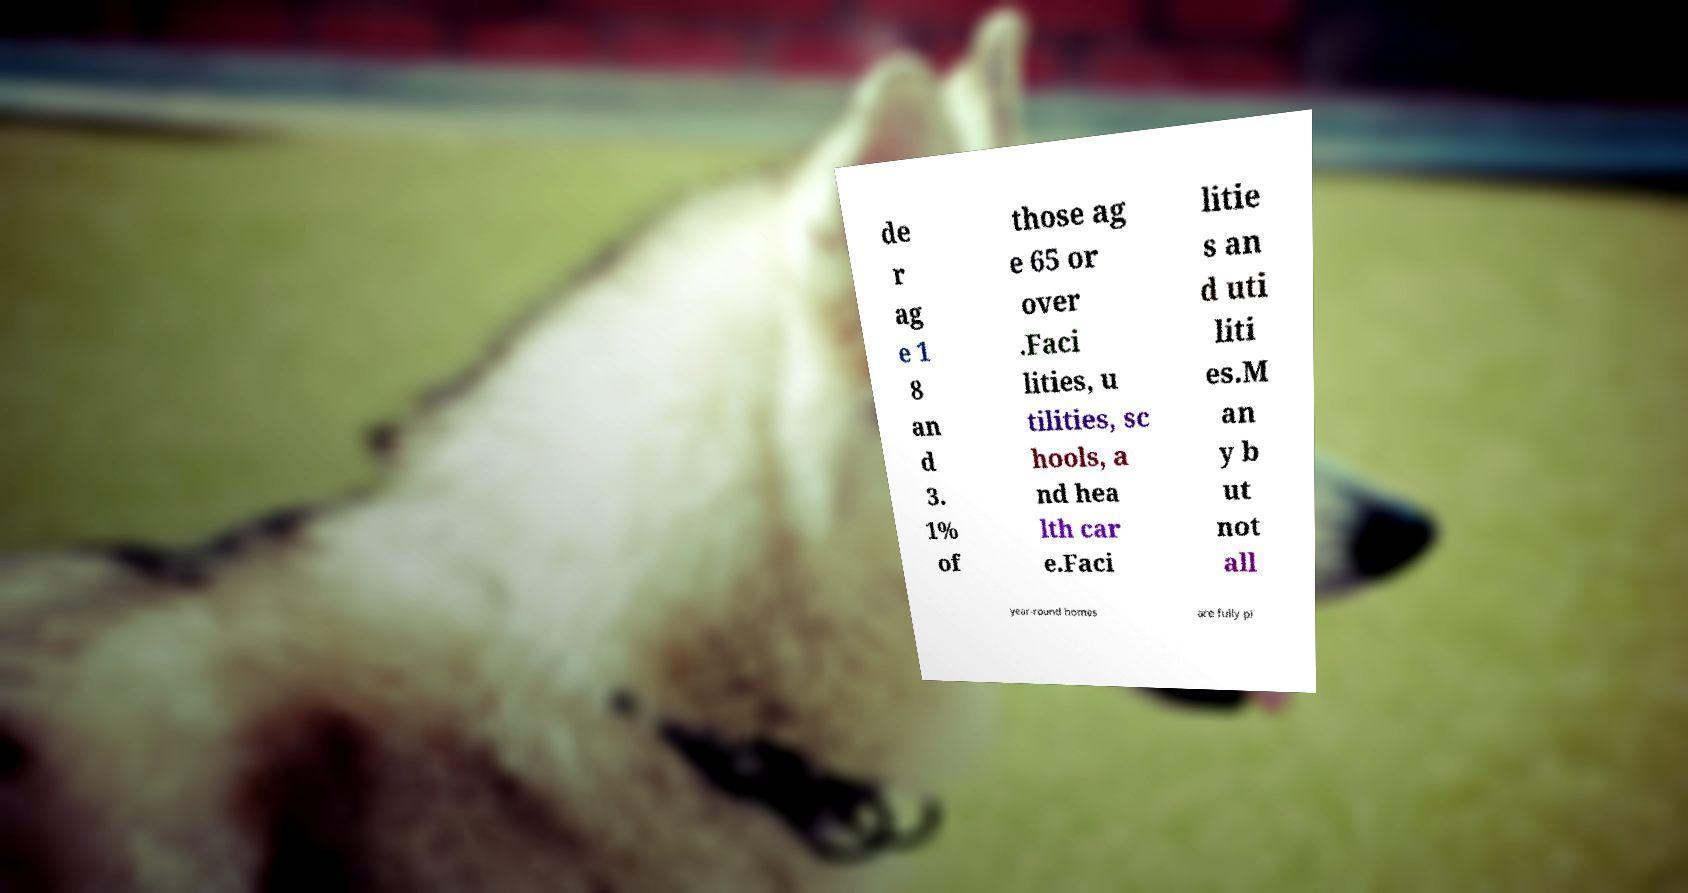There's text embedded in this image that I need extracted. Can you transcribe it verbatim? de r ag e 1 8 an d 3. 1% of those ag e 65 or over .Faci lities, u tilities, sc hools, a nd hea lth car e.Faci litie s an d uti liti es.M an y b ut not all year-round homes are fully pl 